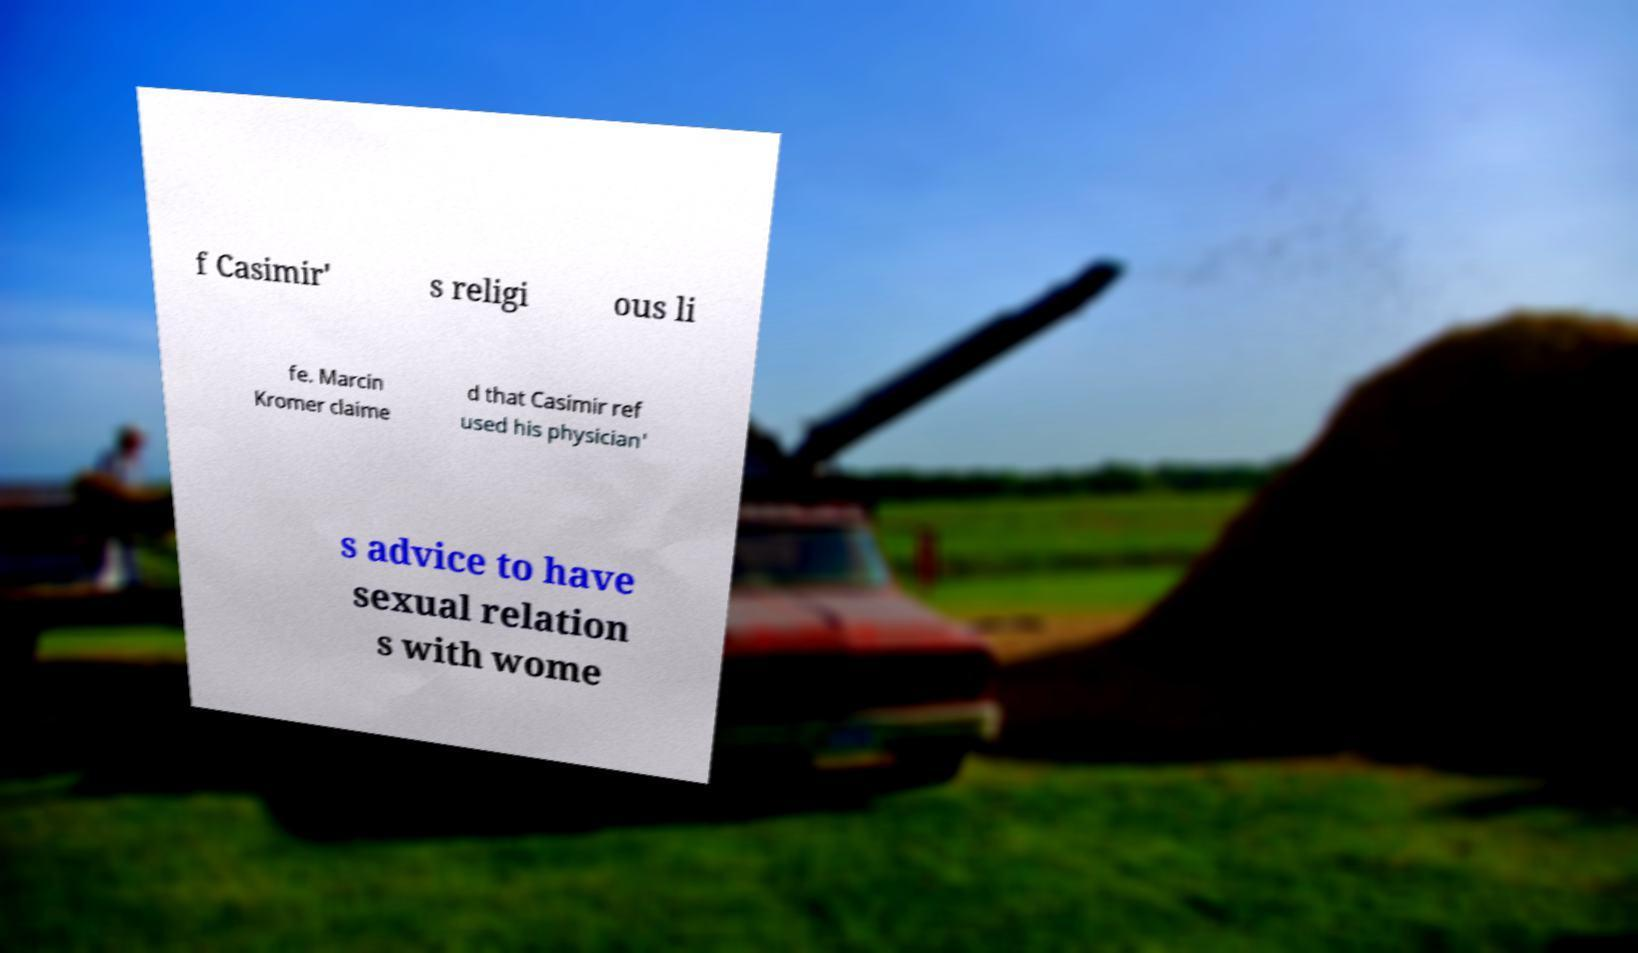What messages or text are displayed in this image? I need them in a readable, typed format. f Casimir' s religi ous li fe. Marcin Kromer claime d that Casimir ref used his physician' s advice to have sexual relation s with wome 